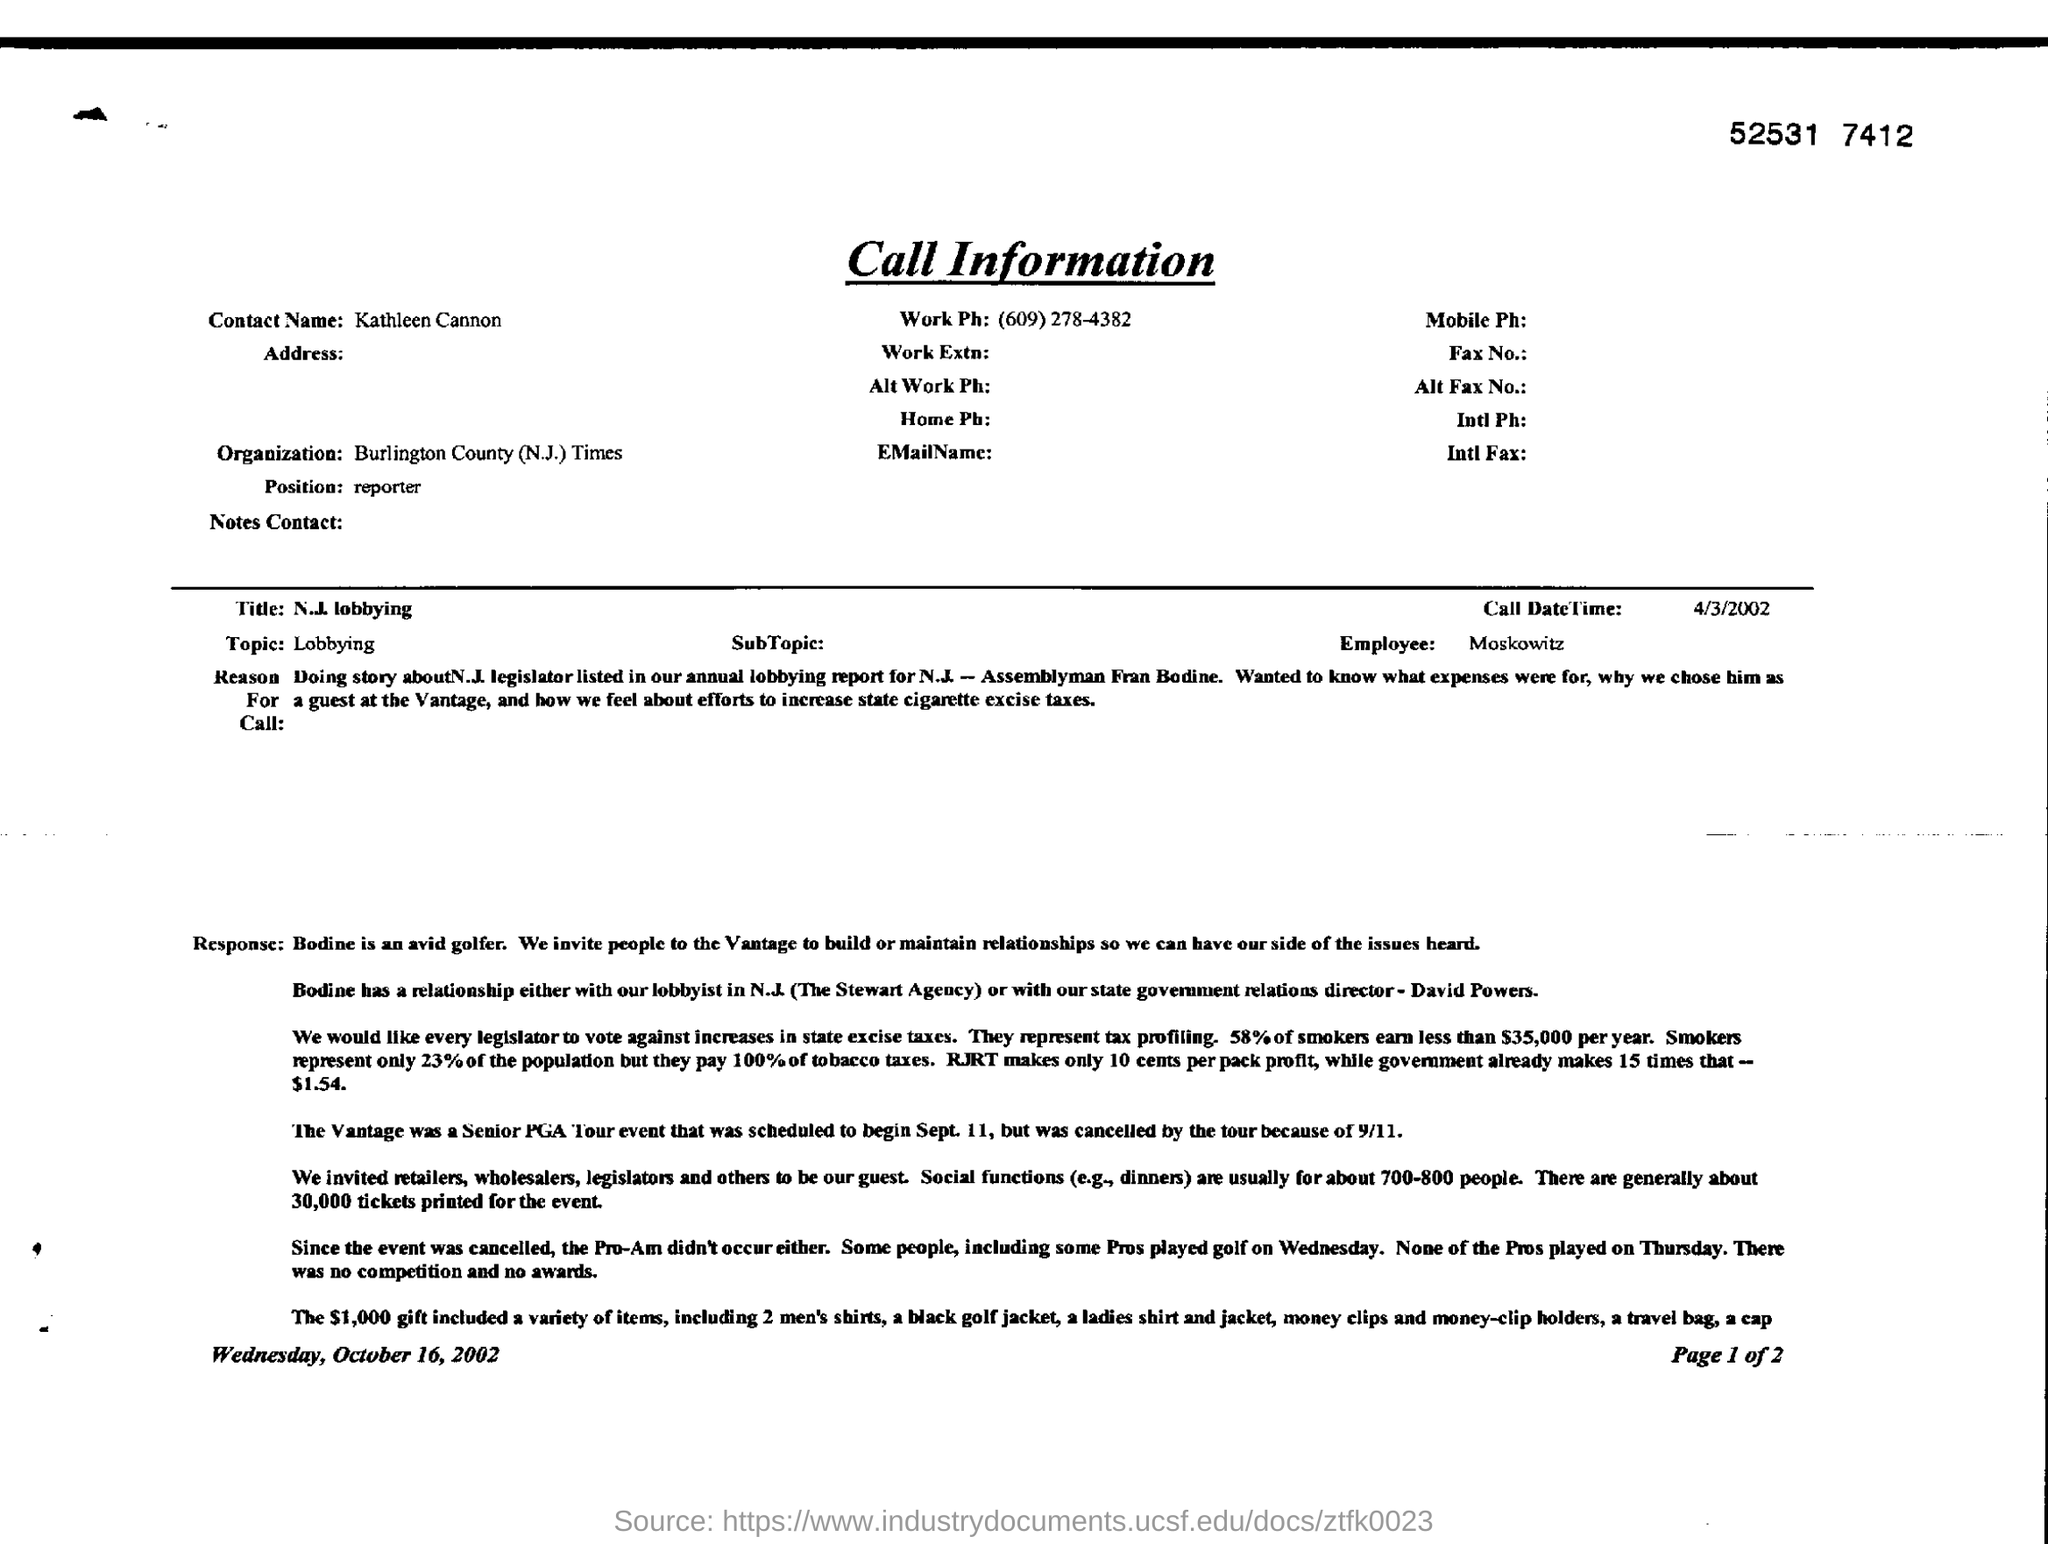What is the "position" marked in the document?
Provide a short and direct response. Reporter. What is written as "Topic"?
Make the answer very short. Lobbying. What is call date time?
Provide a short and direct response. 4/3/2002. Value of gifts including shirts?
Make the answer very short. $ 1000. 